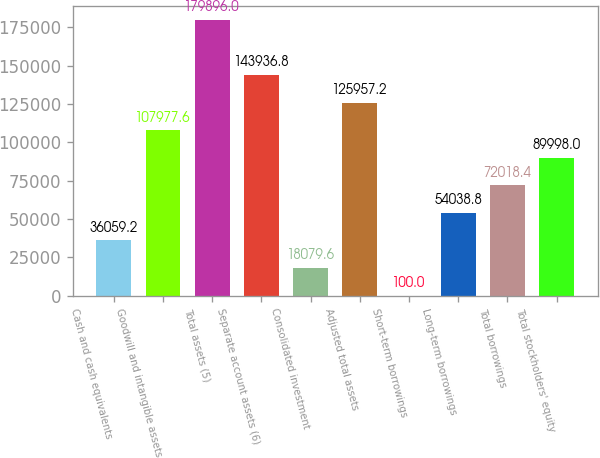Convert chart. <chart><loc_0><loc_0><loc_500><loc_500><bar_chart><fcel>Cash and cash equivalents<fcel>Goodwill and intangible assets<fcel>Total assets (5)<fcel>Separate account assets (6)<fcel>Consolidated investment<fcel>Adjusted total assets<fcel>Short-term borrowings<fcel>Long-term borrowings<fcel>Total borrowings<fcel>Total stockholders' equity<nl><fcel>36059.2<fcel>107978<fcel>179896<fcel>143937<fcel>18079.6<fcel>125957<fcel>100<fcel>54038.8<fcel>72018.4<fcel>89998<nl></chart> 